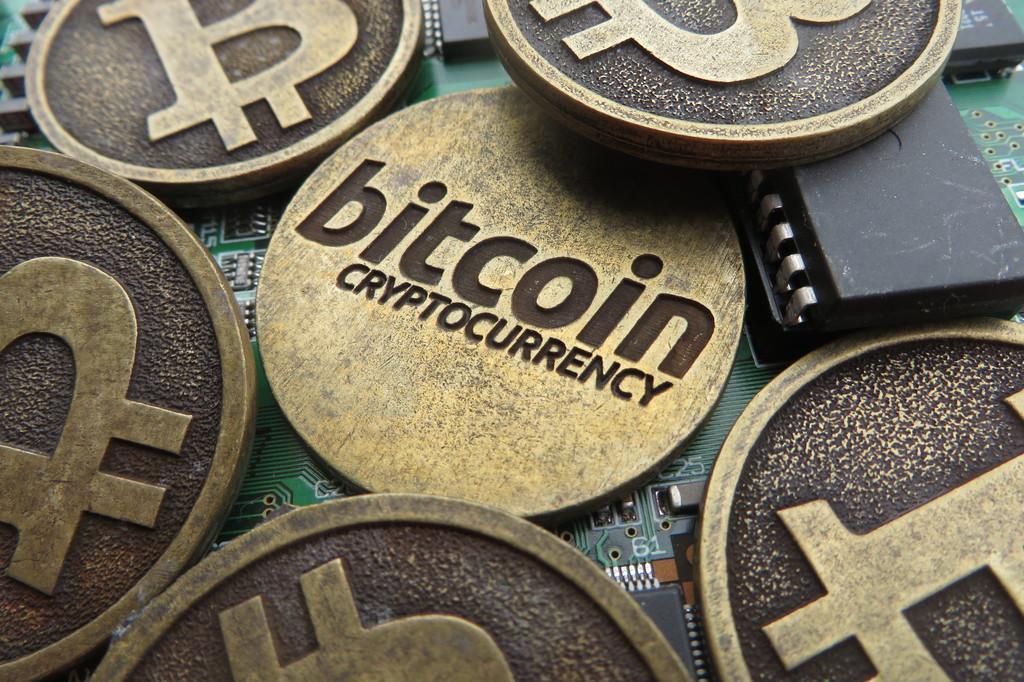In one or two sentences, can you explain what this image depicts? In this picture we can see bronze coins on the Arduino board. 